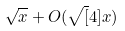<formula> <loc_0><loc_0><loc_500><loc_500>\sqrt { x } + O ( \sqrt { [ } 4 ] { x } )</formula> 